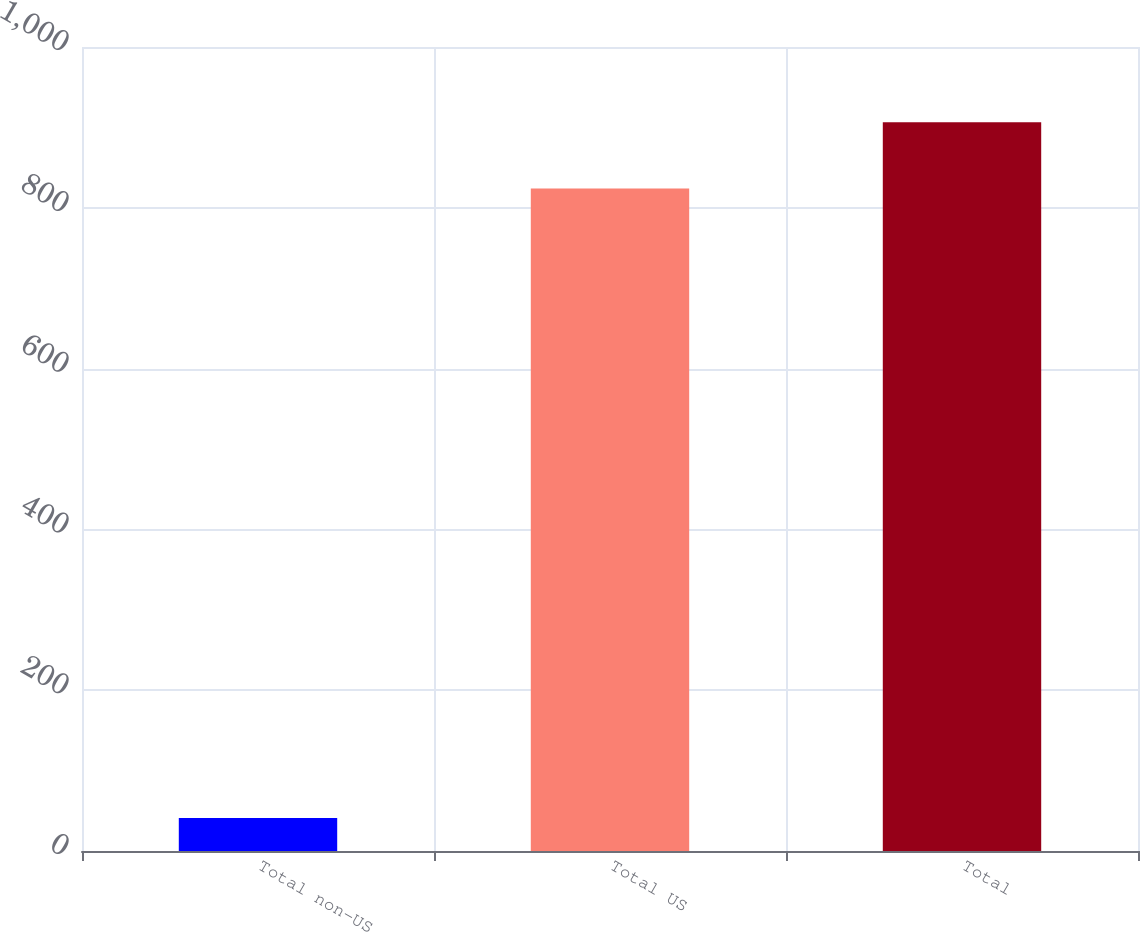<chart> <loc_0><loc_0><loc_500><loc_500><bar_chart><fcel>Total non-US<fcel>Total US<fcel>Total<nl><fcel>41<fcel>824<fcel>906.4<nl></chart> 